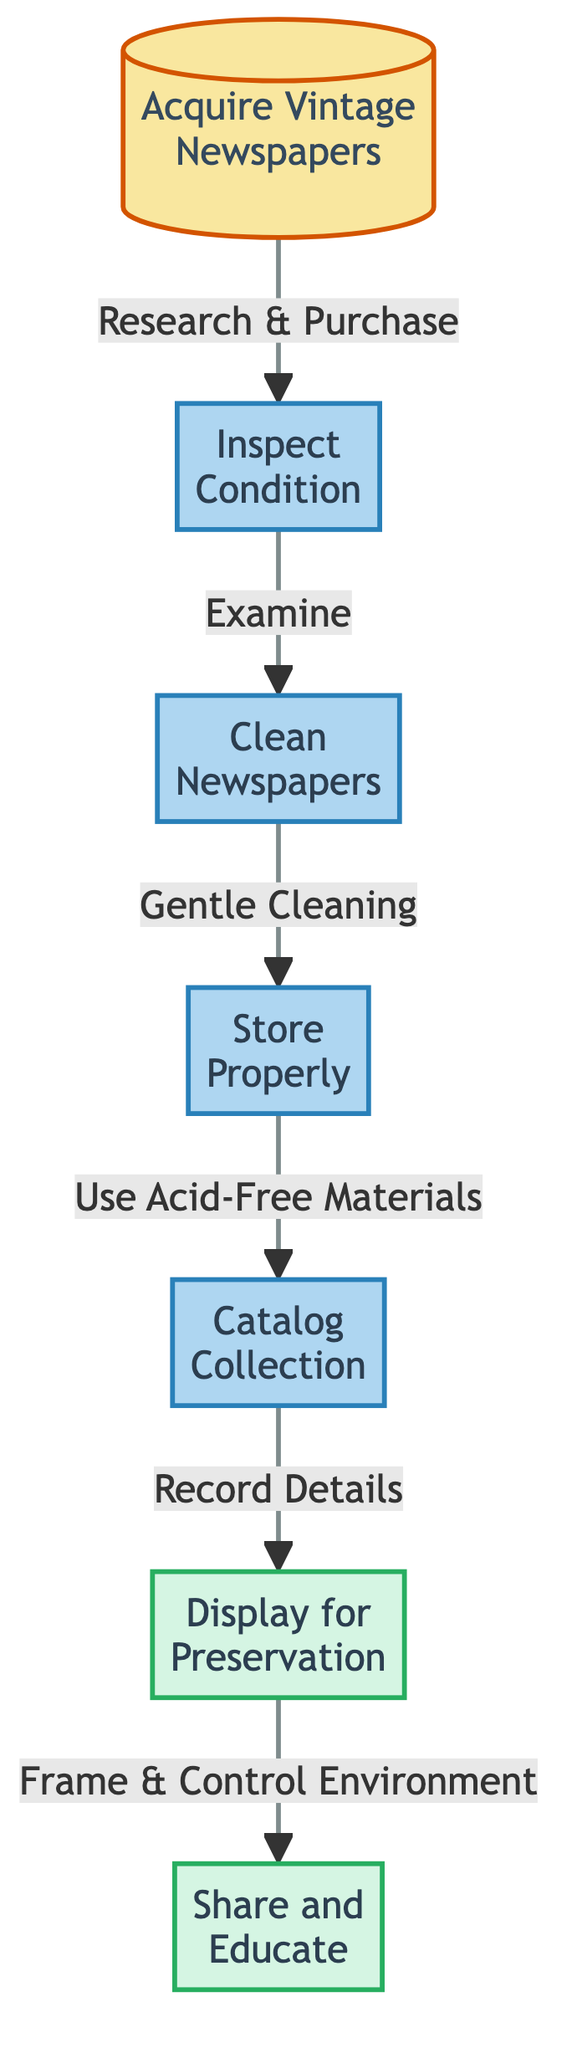What is the first step in the flow? The first step in the flow is "Acquire Vintage Newspapers." This is identified by the first node that initiates the process, which is indicated as step 1 in the flowchart.
Answer: Acquire Vintage Newspapers How many total steps are in the flowchart? The flowchart contains a total of seven steps, as there are seven nodes represented in the diagram, numbered from 1 to 7.
Answer: 7 Which step follows "Clean Newspapers"? The step that follows "Clean Newspapers" is "Store Properly." By examining the flow direction in the diagram, we can see that the arrow from node 3 leads to node 4.
Answer: Store Properly What is the last step in the flow? The last step in the flow is "Share and Educate." This is identified as the final node in the flowchart, denoted as step 7, which concludes the series of actions.
Answer: Share and Educate What process is used after "Inspect Condition"? The process used after "Inspect Condition" is "Clean Newspapers." The flow leads from node 2 to node 3, indicating the action taken after inspecting the condition of the newspapers.
Answer: Clean Newspapers How is “Catalog Collection” related to “Store Properly”? "Catalog Collection" follows "Store Properly" as the fifth step, which is reached after storing the newspapers properly. The flowchart indicates sequential steps with the arrow leading from node 4 to node 5.
Answer: Sequentially What is used for storing newspapers according to the diagram? According to the diagram, "acid-free boxes and sleeves" are used for storing newspapers. This information can be found in the description of node 4 for "Store Properly."
Answer: Acid-free boxes and sleeves What action is taken after displaying for preservation? The action taken after displaying for preservation is to "Share and Educate." The diagram shows that this step occurs after the display process in a controlled environment.
Answer: Share and Educate 